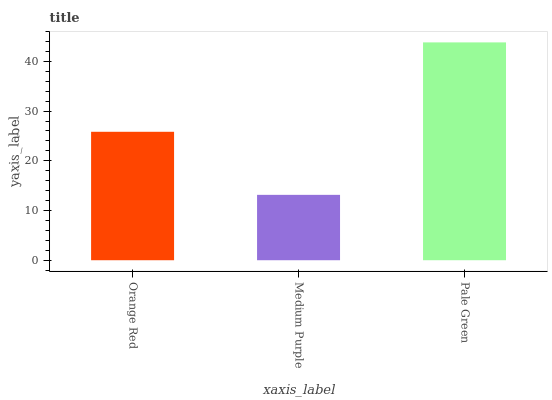Is Medium Purple the minimum?
Answer yes or no. Yes. Is Pale Green the maximum?
Answer yes or no. Yes. Is Pale Green the minimum?
Answer yes or no. No. Is Medium Purple the maximum?
Answer yes or no. No. Is Pale Green greater than Medium Purple?
Answer yes or no. Yes. Is Medium Purple less than Pale Green?
Answer yes or no. Yes. Is Medium Purple greater than Pale Green?
Answer yes or no. No. Is Pale Green less than Medium Purple?
Answer yes or no. No. Is Orange Red the high median?
Answer yes or no. Yes. Is Orange Red the low median?
Answer yes or no. Yes. Is Medium Purple the high median?
Answer yes or no. No. Is Medium Purple the low median?
Answer yes or no. No. 